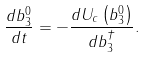<formula> <loc_0><loc_0><loc_500><loc_500>\frac { d b _ { 3 } ^ { 0 } } { d t } = - \frac { { d U _ { c } \left ( { b _ { 3 } ^ { 0 } } \right ) } } { d b _ { 3 } ^ { \dag } } .</formula> 